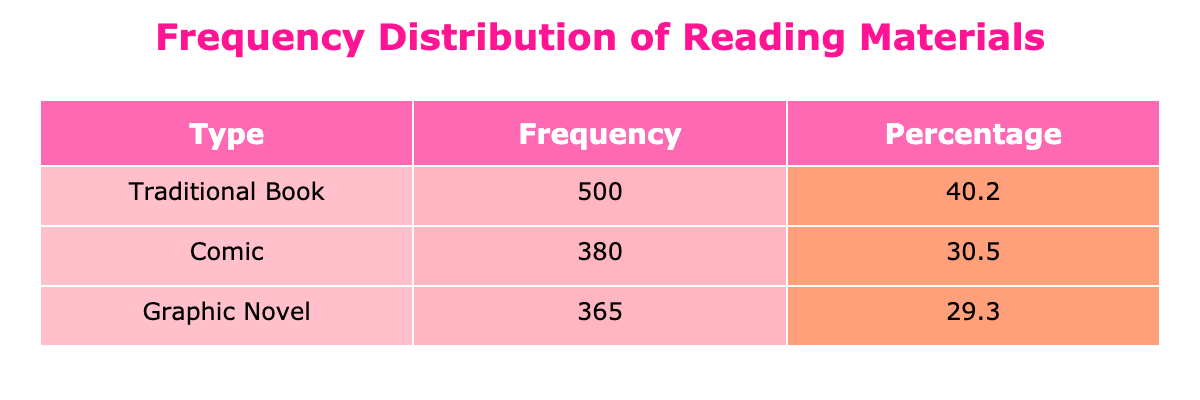What is the frequency of the traditional book "Harry Potter and the Sorcerer's Stone"? The table directly lists the frequency for "Harry Potter and the Sorcerer's Stone" under the Traditional Book category, which is 140.
Answer: 140 Which type of reading material has the highest total frequency? Looking at the total frequencies for each type—Graphic Novels (120 + 95 + 80 + 70 = 365), Traditional Books (150 + 140 + 100 + 110 = 500), and Comics (130 + 90 + 75 + 85 = 380)—Traditional Books has the highest total frequency of 500.
Answer: Traditional Books What percentage of teenagers prefer graphic novels compared to the total? The total frequency of all reading materials is 365 (Graphic Novels) + 500 (Traditional Books) + 380 (Comics) = 1245. The percentage of graphic novels is (365 / 1245) * 100 = 29.3%.
Answer: 29.3% Is the frequency of "Persepolis" higher than that of "Batman: Year One"? The frequency for "Persepolis" is 70, while for "Batman: Year One" it is 90. Since 70 is less than 90, the statement is false.
Answer: No What is the average frequency of all graphic novels combined? The total frequency for graphic novels is 120 + 95 + 80 + 70 = 365. There are 4 graphic novels, so the average frequency is 365 / 4 = 91.25.
Answer: 91.25 Which comic has the lowest frequency? By comparing the frequencies listed for each comic: Spider-Man (130), Batman (90), The Sandman (75), and X-Men (85). The Sandman has the lowest frequency of 75.
Answer: The Sandman How many more traditional books are preferred than comics? The total frequency of traditional books is 500, while for comics it is 380. The difference is 500 - 380 = 120.
Answer: 120 What proportion of the total frequency do the comics represent? The total frequency across all categories is 1245. The frequency of comics is 380. So, the proportion of comics is (380 / 1245) * 100 = 30.5%.
Answer: 30.5% 